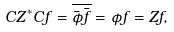<formula> <loc_0><loc_0><loc_500><loc_500>C Z ^ { \ast } C f = \overline { \bar { \phi } \bar { f } } = \phi f = Z f ,</formula> 